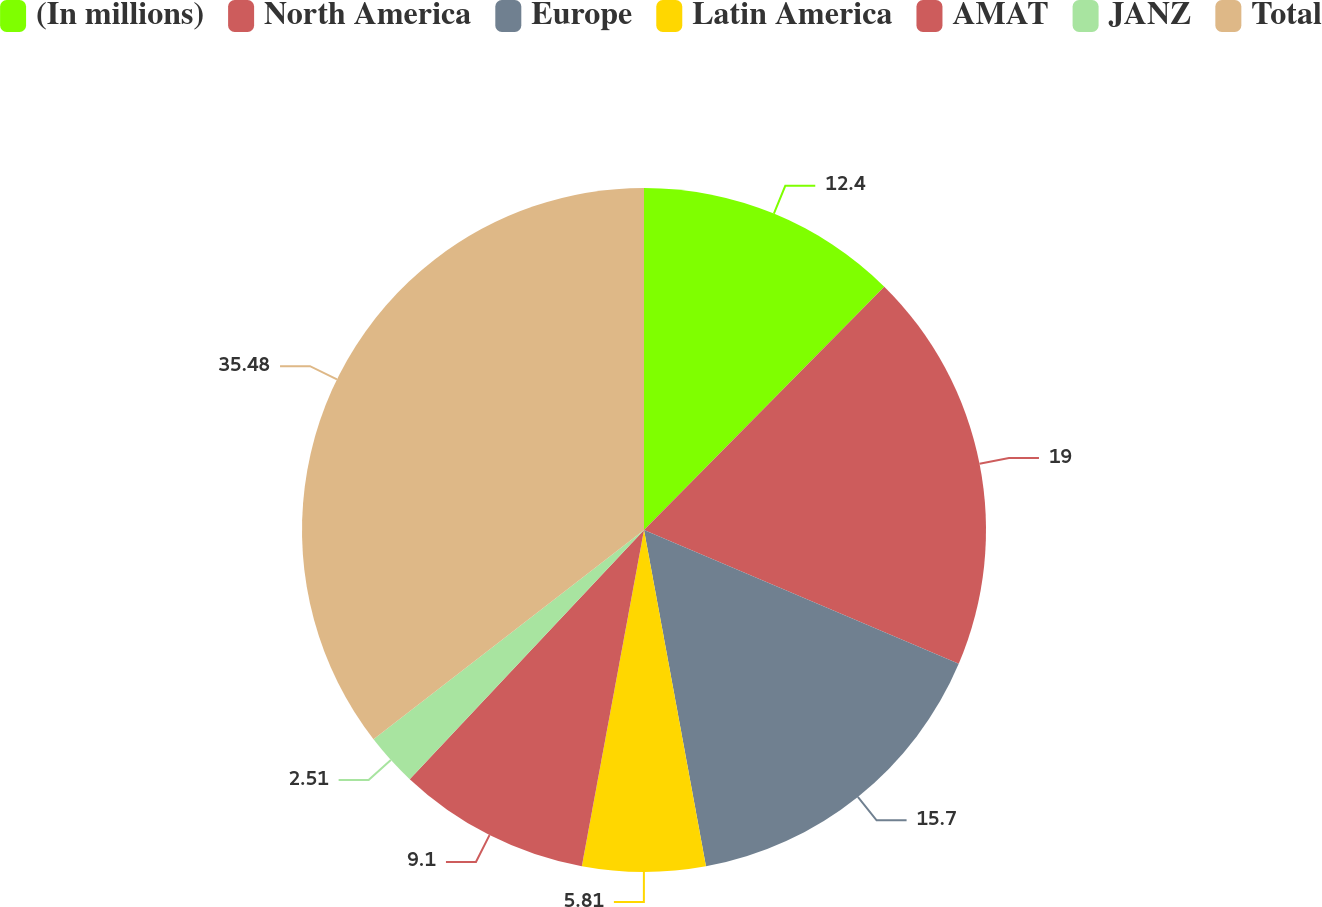<chart> <loc_0><loc_0><loc_500><loc_500><pie_chart><fcel>(In millions)<fcel>North America<fcel>Europe<fcel>Latin America<fcel>AMAT<fcel>JANZ<fcel>Total<nl><fcel>12.4%<fcel>19.0%<fcel>15.7%<fcel>5.81%<fcel>9.1%<fcel>2.51%<fcel>35.48%<nl></chart> 